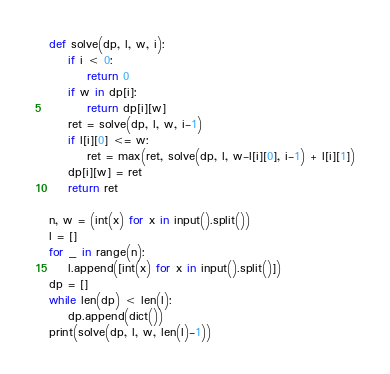Convert code to text. <code><loc_0><loc_0><loc_500><loc_500><_Python_>def solve(dp, l, w, i):
    if i < 0:
        return 0
    if w in dp[i]:
        return dp[i][w]
    ret = solve(dp, l, w, i-1)
    if l[i][0] <= w:
        ret = max(ret, solve(dp, l, w-l[i][0], i-1) + l[i][1])
    dp[i][w] = ret
    return ret

n, w = (int(x) for x in input().split())
l = []
for _ in range(n):
    l.append([int(x) for x in input().split()])
dp = []
while len(dp) < len(l):
    dp.append(dict())
print(solve(dp, l, w, len(l)-1))
</code> 